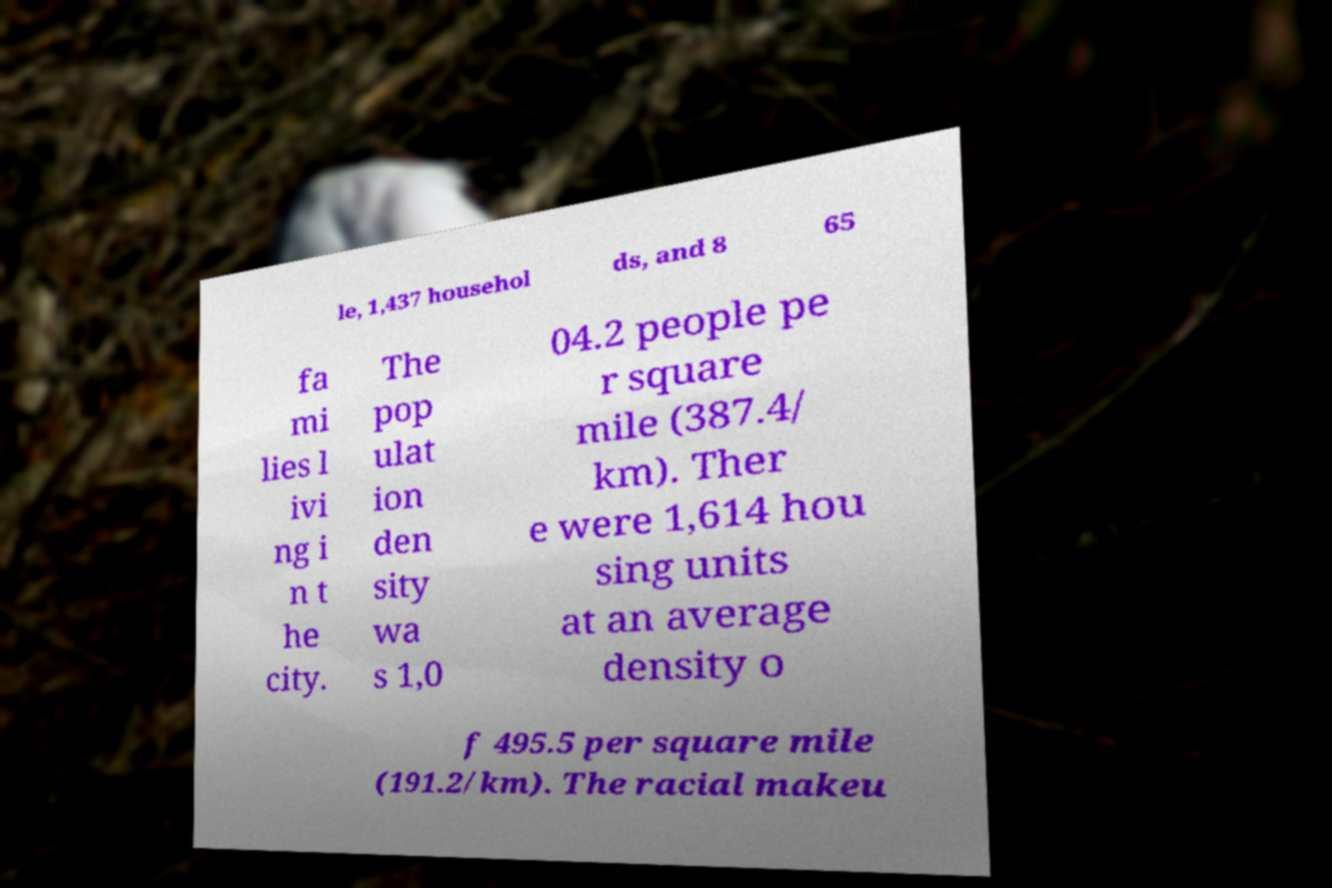Can you read and provide the text displayed in the image?This photo seems to have some interesting text. Can you extract and type it out for me? le, 1,437 househol ds, and 8 65 fa mi lies l ivi ng i n t he city. The pop ulat ion den sity wa s 1,0 04.2 people pe r square mile (387.4/ km). Ther e were 1,614 hou sing units at an average density o f 495.5 per square mile (191.2/km). The racial makeu 